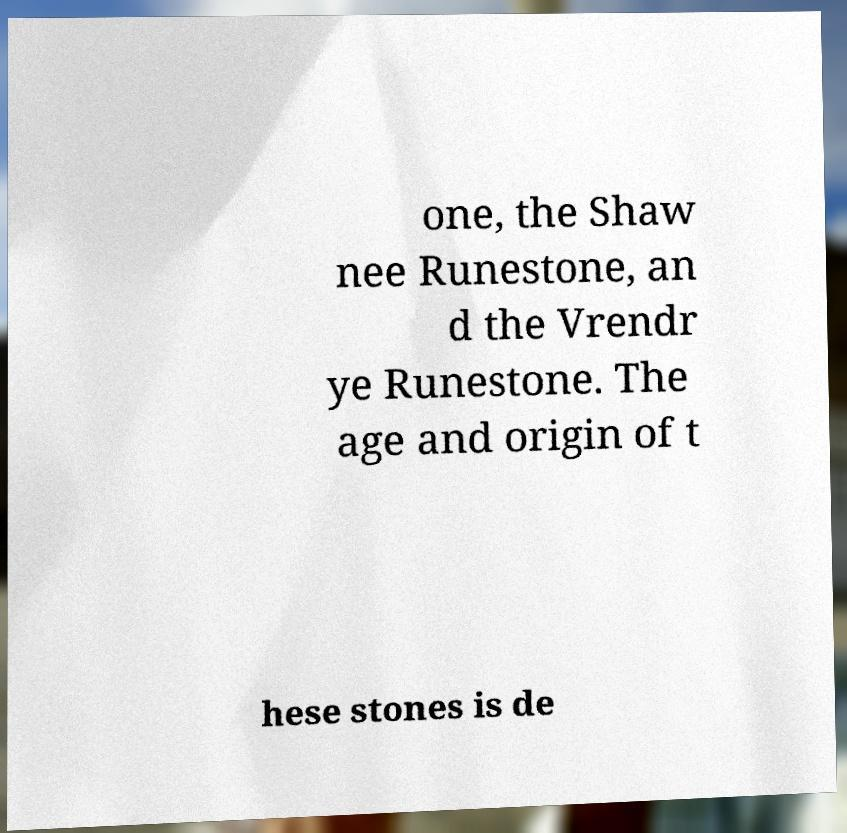I need the written content from this picture converted into text. Can you do that? one, the Shaw nee Runestone, an d the Vrendr ye Runestone. The age and origin of t hese stones is de 